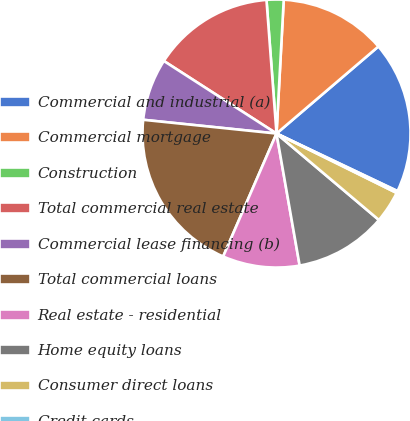<chart> <loc_0><loc_0><loc_500><loc_500><pie_chart><fcel>Commercial and industrial (a)<fcel>Commercial mortgage<fcel>Construction<fcel>Total commercial real estate<fcel>Commercial lease financing (b)<fcel>Total commercial loans<fcel>Real estate - residential<fcel>Home equity loans<fcel>Consumer direct loans<fcel>Credit cards<nl><fcel>18.32%<fcel>12.89%<fcel>2.05%<fcel>14.7%<fcel>7.47%<fcel>20.12%<fcel>9.28%<fcel>11.08%<fcel>3.85%<fcel>0.24%<nl></chart> 